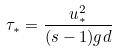<formula> <loc_0><loc_0><loc_500><loc_500>\tau _ { * } = \frac { u _ { * } ^ { 2 } } { ( s - 1 ) g d }</formula> 